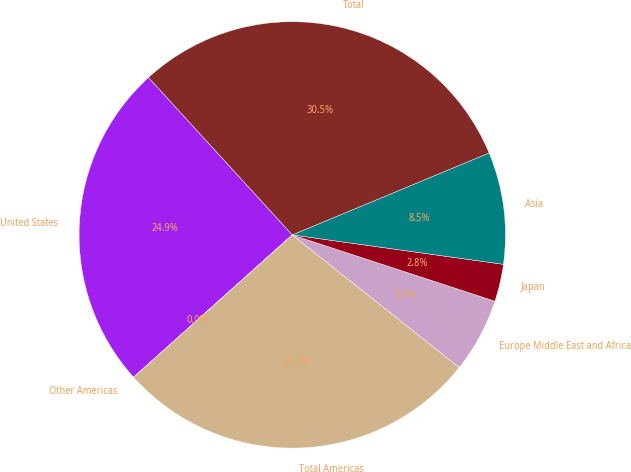Convert chart. <chart><loc_0><loc_0><loc_500><loc_500><pie_chart><fcel>United States<fcel>Other Americas<fcel>Total Americas<fcel>Europe Middle East and Africa<fcel>Japan<fcel>Asia<fcel>Total<nl><fcel>24.85%<fcel>0.0%<fcel>27.68%<fcel>5.65%<fcel>2.83%<fcel>8.48%<fcel>30.5%<nl></chart> 